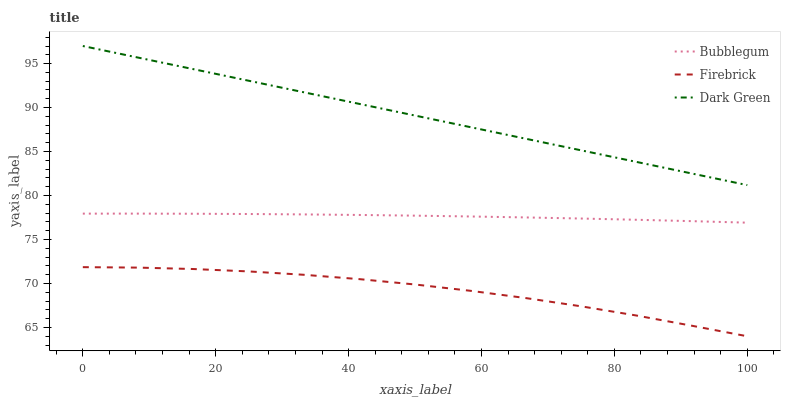Does Bubblegum have the minimum area under the curve?
Answer yes or no. No. Does Bubblegum have the maximum area under the curve?
Answer yes or no. No. Is Bubblegum the smoothest?
Answer yes or no. No. Is Bubblegum the roughest?
Answer yes or no. No. Does Bubblegum have the lowest value?
Answer yes or no. No. Does Bubblegum have the highest value?
Answer yes or no. No. Is Bubblegum less than Dark Green?
Answer yes or no. Yes. Is Dark Green greater than Firebrick?
Answer yes or no. Yes. Does Bubblegum intersect Dark Green?
Answer yes or no. No. 